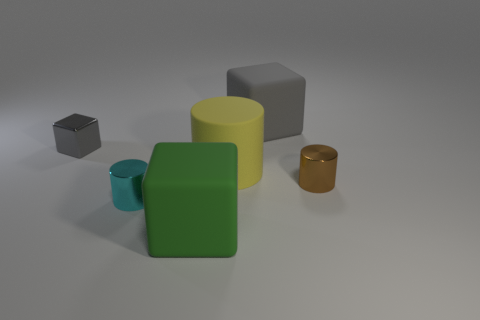Add 4 small gray things. How many objects exist? 10 Subtract all metallic blocks. How many blocks are left? 2 Add 3 tiny cyan cylinders. How many tiny cyan cylinders exist? 4 Subtract all gray cubes. How many cubes are left? 1 Subtract 0 purple spheres. How many objects are left? 6 Subtract 3 cylinders. How many cylinders are left? 0 Subtract all brown cylinders. Subtract all cyan blocks. How many cylinders are left? 2 Subtract all green blocks. How many blue cylinders are left? 0 Subtract all large things. Subtract all small purple matte cylinders. How many objects are left? 3 Add 2 tiny blocks. How many tiny blocks are left? 3 